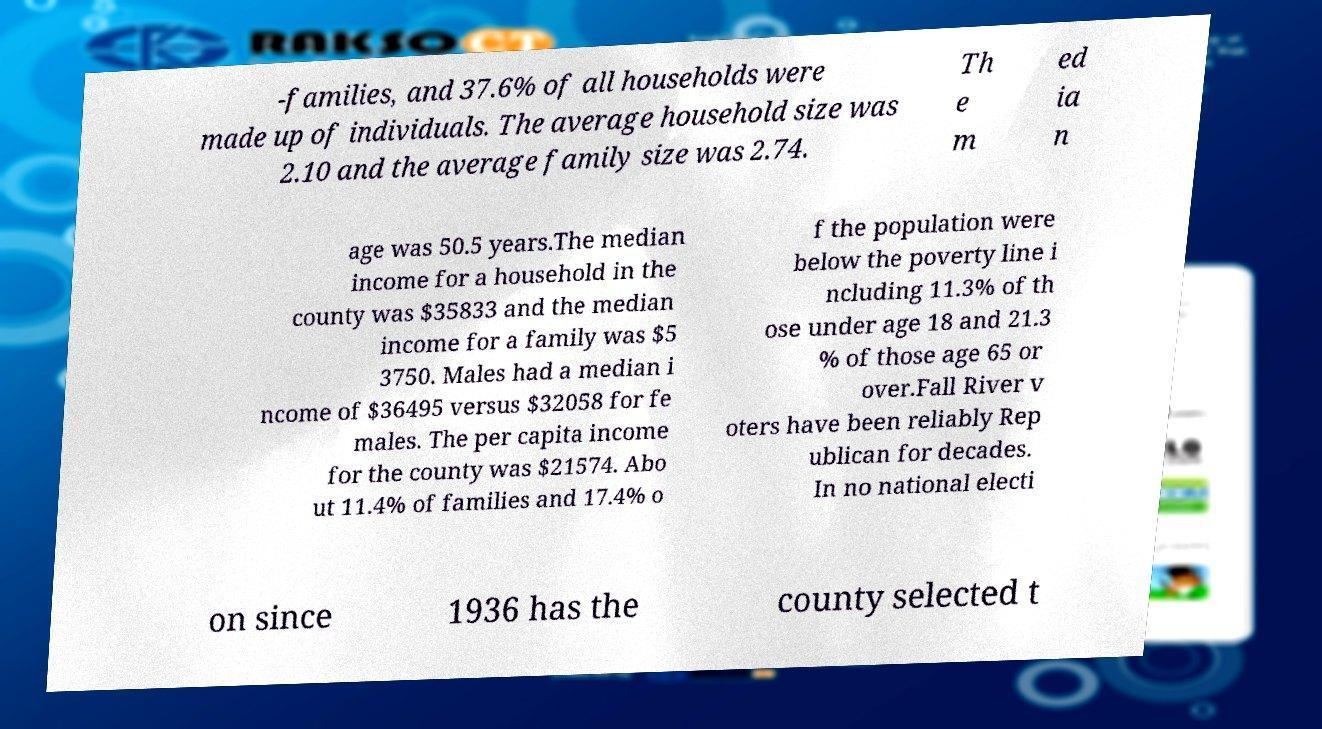Please read and relay the text visible in this image. What does it say? -families, and 37.6% of all households were made up of individuals. The average household size was 2.10 and the average family size was 2.74. Th e m ed ia n age was 50.5 years.The median income for a household in the county was $35833 and the median income for a family was $5 3750. Males had a median i ncome of $36495 versus $32058 for fe males. The per capita income for the county was $21574. Abo ut 11.4% of families and 17.4% o f the population were below the poverty line i ncluding 11.3% of th ose under age 18 and 21.3 % of those age 65 or over.Fall River v oters have been reliably Rep ublican for decades. In no national electi on since 1936 has the county selected t 